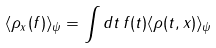Convert formula to latex. <formula><loc_0><loc_0><loc_500><loc_500>\langle \rho _ { x } ( f ) \rangle _ { \psi } = \int d t \, f ( t ) \langle \rho ( t , x ) \rangle _ { \psi }</formula> 